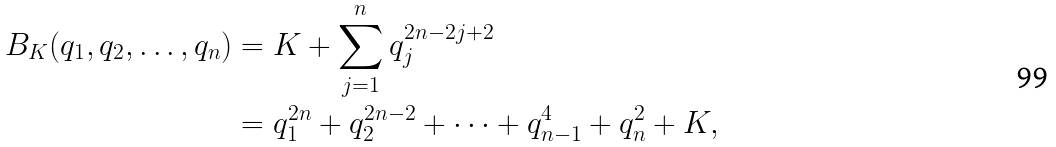<formula> <loc_0><loc_0><loc_500><loc_500>B _ { K } ( q _ { 1 } , q _ { 2 } , \dots , q _ { n } ) & = K + \sum _ { j = 1 } ^ { n } q _ { j } ^ { 2 n - 2 j + 2 } \\ & = q _ { 1 } ^ { 2 n } + q _ { 2 } ^ { 2 n - 2 } + \dots + q _ { n - 1 } ^ { 4 } + q _ { n } ^ { 2 } + K ,</formula> 